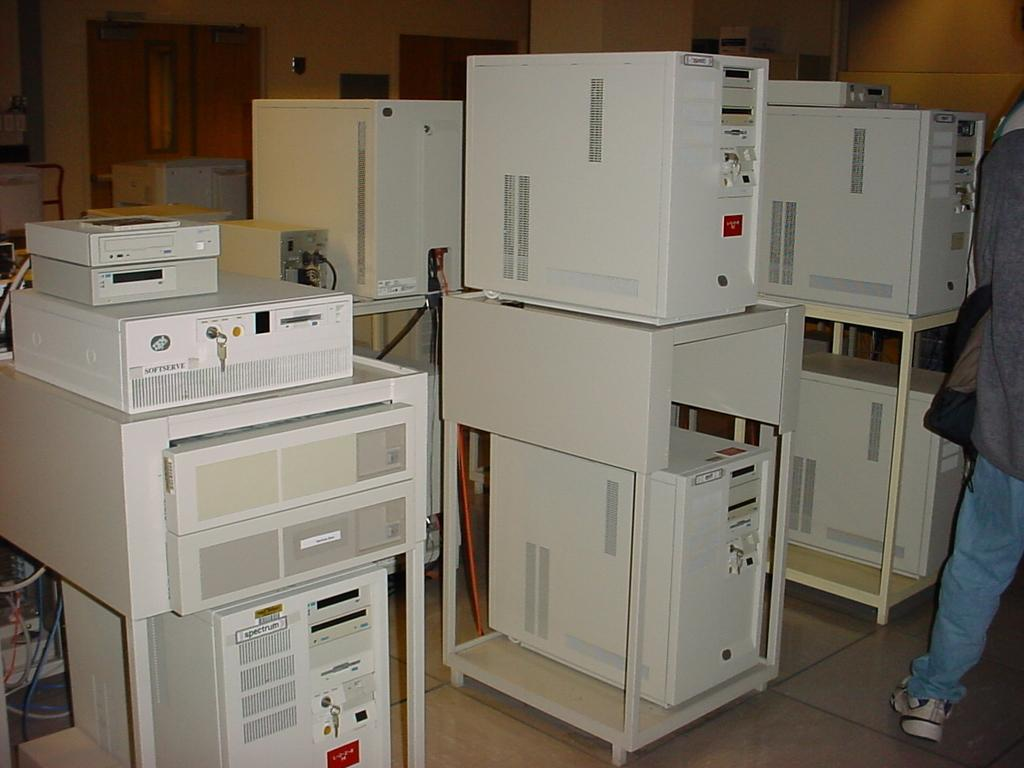What objects are on stands in the image? There are electronic devices on stands in the image. Where is the person located in the image? The person is standing on the right side of the image. What can be seen in the background of the image? There is a wall in the background of the image. Can you tell me how many cows are visible in the image? There are no cows present in the image. What type of stretch is the person doing in the image? The person is not stretching in the image; they are simply standing on the right side. 